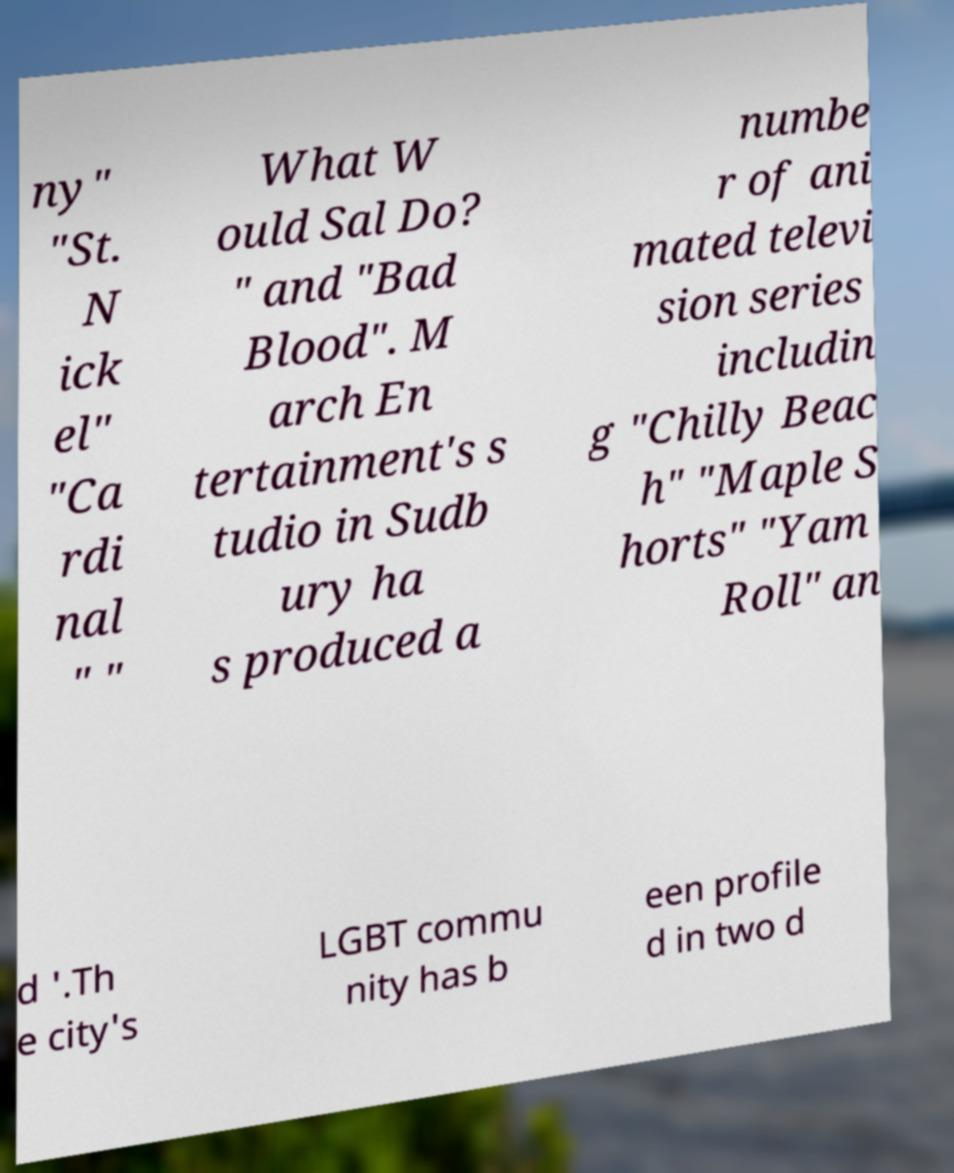I need the written content from this picture converted into text. Can you do that? ny" "St. N ick el" "Ca rdi nal " " What W ould Sal Do? " and "Bad Blood". M arch En tertainment's s tudio in Sudb ury ha s produced a numbe r of ani mated televi sion series includin g "Chilly Beac h" "Maple S horts" "Yam Roll" an d '.Th e city's LGBT commu nity has b een profile d in two d 